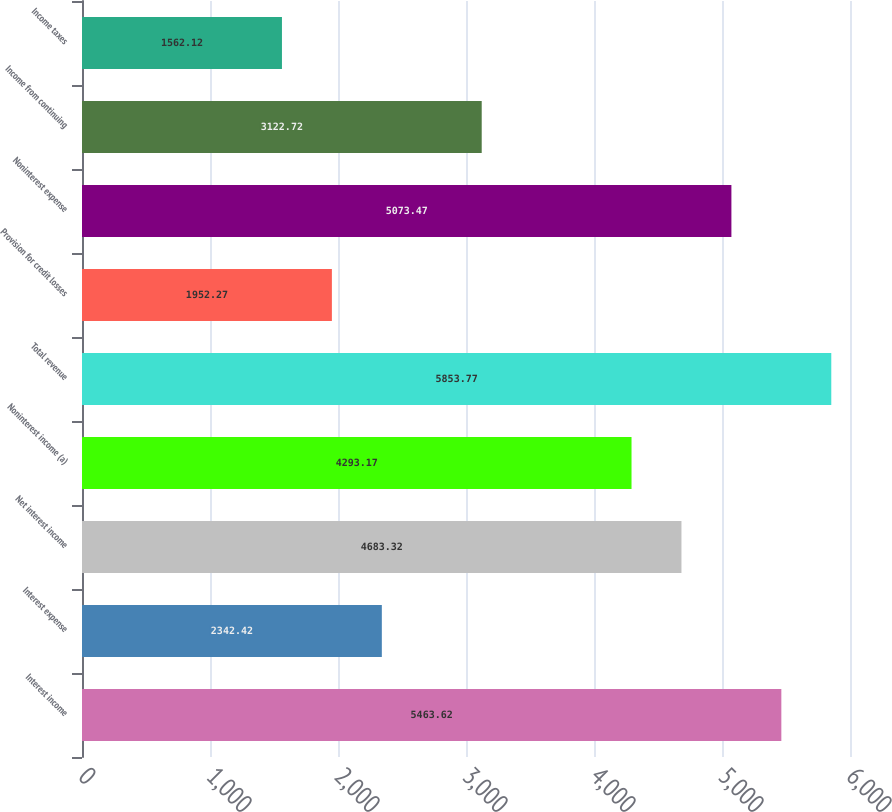Convert chart. <chart><loc_0><loc_0><loc_500><loc_500><bar_chart><fcel>Interest income<fcel>Interest expense<fcel>Net interest income<fcel>Noninterest income (a)<fcel>Total revenue<fcel>Provision for credit losses<fcel>Noninterest expense<fcel>Income from continuing<fcel>Income taxes<nl><fcel>5463.62<fcel>2342.42<fcel>4683.32<fcel>4293.17<fcel>5853.77<fcel>1952.27<fcel>5073.47<fcel>3122.72<fcel>1562.12<nl></chart> 